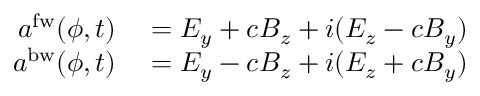<formula> <loc_0><loc_0><loc_500><loc_500>\begin{array} { r l } { a ^ { f w } ( \phi , t ) } & = E _ { y } + c B _ { z } + i ( E _ { z } - c B _ { y } ) } \\ { a ^ { b w } ( \phi , t ) } & = E _ { y } - c B _ { z } + i ( E _ { z } + c B _ { y } ) } \end{array}</formula> 